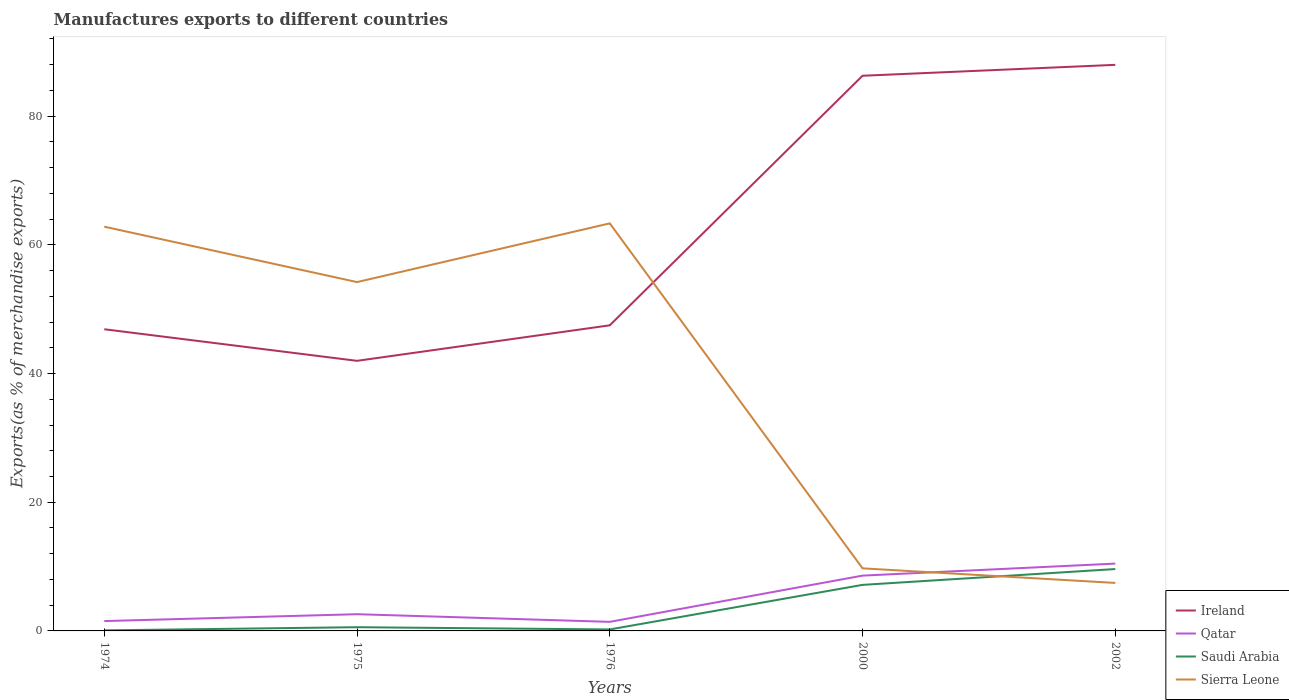How many different coloured lines are there?
Give a very brief answer. 4. Across all years, what is the maximum percentage of exports to different countries in Saudi Arabia?
Keep it short and to the point. 0.09. In which year was the percentage of exports to different countries in Qatar maximum?
Give a very brief answer. 1976. What is the total percentage of exports to different countries in Sierra Leone in the graph?
Keep it short and to the point. -9.13. What is the difference between the highest and the second highest percentage of exports to different countries in Sierra Leone?
Provide a short and direct response. 55.88. How many lines are there?
Your response must be concise. 4. How many years are there in the graph?
Keep it short and to the point. 5. What is the difference between two consecutive major ticks on the Y-axis?
Make the answer very short. 20. Does the graph contain any zero values?
Give a very brief answer. No. Where does the legend appear in the graph?
Provide a short and direct response. Bottom right. How are the legend labels stacked?
Offer a terse response. Vertical. What is the title of the graph?
Your response must be concise. Manufactures exports to different countries. Does "Vietnam" appear as one of the legend labels in the graph?
Give a very brief answer. No. What is the label or title of the X-axis?
Ensure brevity in your answer.  Years. What is the label or title of the Y-axis?
Your answer should be very brief. Exports(as % of merchandise exports). What is the Exports(as % of merchandise exports) of Ireland in 1974?
Your response must be concise. 46.88. What is the Exports(as % of merchandise exports) of Qatar in 1974?
Provide a short and direct response. 1.53. What is the Exports(as % of merchandise exports) of Saudi Arabia in 1974?
Provide a succinct answer. 0.09. What is the Exports(as % of merchandise exports) of Sierra Leone in 1974?
Your response must be concise. 62.82. What is the Exports(as % of merchandise exports) in Ireland in 1975?
Your answer should be compact. 41.97. What is the Exports(as % of merchandise exports) in Qatar in 1975?
Provide a short and direct response. 2.6. What is the Exports(as % of merchandise exports) of Saudi Arabia in 1975?
Give a very brief answer. 0.58. What is the Exports(as % of merchandise exports) in Sierra Leone in 1975?
Your response must be concise. 54.21. What is the Exports(as % of merchandise exports) in Ireland in 1976?
Make the answer very short. 47.49. What is the Exports(as % of merchandise exports) in Qatar in 1976?
Offer a very short reply. 1.41. What is the Exports(as % of merchandise exports) in Saudi Arabia in 1976?
Give a very brief answer. 0.23. What is the Exports(as % of merchandise exports) of Sierra Leone in 1976?
Give a very brief answer. 63.34. What is the Exports(as % of merchandise exports) in Ireland in 2000?
Provide a succinct answer. 86.28. What is the Exports(as % of merchandise exports) in Qatar in 2000?
Your answer should be compact. 8.59. What is the Exports(as % of merchandise exports) in Saudi Arabia in 2000?
Your answer should be compact. 7.16. What is the Exports(as % of merchandise exports) in Sierra Leone in 2000?
Ensure brevity in your answer.  9.73. What is the Exports(as % of merchandise exports) of Ireland in 2002?
Keep it short and to the point. 87.97. What is the Exports(as % of merchandise exports) in Qatar in 2002?
Keep it short and to the point. 10.46. What is the Exports(as % of merchandise exports) in Saudi Arabia in 2002?
Your answer should be very brief. 9.62. What is the Exports(as % of merchandise exports) in Sierra Leone in 2002?
Keep it short and to the point. 7.46. Across all years, what is the maximum Exports(as % of merchandise exports) in Ireland?
Your answer should be compact. 87.97. Across all years, what is the maximum Exports(as % of merchandise exports) of Qatar?
Your answer should be compact. 10.46. Across all years, what is the maximum Exports(as % of merchandise exports) of Saudi Arabia?
Your answer should be very brief. 9.62. Across all years, what is the maximum Exports(as % of merchandise exports) in Sierra Leone?
Your answer should be compact. 63.34. Across all years, what is the minimum Exports(as % of merchandise exports) in Ireland?
Ensure brevity in your answer.  41.97. Across all years, what is the minimum Exports(as % of merchandise exports) in Qatar?
Provide a short and direct response. 1.41. Across all years, what is the minimum Exports(as % of merchandise exports) of Saudi Arabia?
Provide a succinct answer. 0.09. Across all years, what is the minimum Exports(as % of merchandise exports) of Sierra Leone?
Your answer should be compact. 7.46. What is the total Exports(as % of merchandise exports) in Ireland in the graph?
Make the answer very short. 310.6. What is the total Exports(as % of merchandise exports) of Qatar in the graph?
Your answer should be compact. 24.6. What is the total Exports(as % of merchandise exports) of Saudi Arabia in the graph?
Your answer should be compact. 17.67. What is the total Exports(as % of merchandise exports) in Sierra Leone in the graph?
Offer a very short reply. 197.55. What is the difference between the Exports(as % of merchandise exports) in Ireland in 1974 and that in 1975?
Offer a very short reply. 4.91. What is the difference between the Exports(as % of merchandise exports) in Qatar in 1974 and that in 1975?
Provide a succinct answer. -1.07. What is the difference between the Exports(as % of merchandise exports) in Saudi Arabia in 1974 and that in 1975?
Provide a short and direct response. -0.49. What is the difference between the Exports(as % of merchandise exports) in Sierra Leone in 1974 and that in 1975?
Offer a terse response. 8.61. What is the difference between the Exports(as % of merchandise exports) in Ireland in 1974 and that in 1976?
Make the answer very short. -0.61. What is the difference between the Exports(as % of merchandise exports) of Qatar in 1974 and that in 1976?
Your answer should be compact. 0.12. What is the difference between the Exports(as % of merchandise exports) in Saudi Arabia in 1974 and that in 1976?
Keep it short and to the point. -0.14. What is the difference between the Exports(as % of merchandise exports) of Sierra Leone in 1974 and that in 1976?
Give a very brief answer. -0.52. What is the difference between the Exports(as % of merchandise exports) of Ireland in 1974 and that in 2000?
Give a very brief answer. -39.39. What is the difference between the Exports(as % of merchandise exports) of Qatar in 1974 and that in 2000?
Ensure brevity in your answer.  -7.06. What is the difference between the Exports(as % of merchandise exports) in Saudi Arabia in 1974 and that in 2000?
Give a very brief answer. -7.07. What is the difference between the Exports(as % of merchandise exports) of Sierra Leone in 1974 and that in 2000?
Offer a very short reply. 53.1. What is the difference between the Exports(as % of merchandise exports) of Ireland in 1974 and that in 2002?
Ensure brevity in your answer.  -41.09. What is the difference between the Exports(as % of merchandise exports) in Qatar in 1974 and that in 2002?
Ensure brevity in your answer.  -8.93. What is the difference between the Exports(as % of merchandise exports) in Saudi Arabia in 1974 and that in 2002?
Make the answer very short. -9.53. What is the difference between the Exports(as % of merchandise exports) of Sierra Leone in 1974 and that in 2002?
Your response must be concise. 55.36. What is the difference between the Exports(as % of merchandise exports) in Ireland in 1975 and that in 1976?
Provide a succinct answer. -5.52. What is the difference between the Exports(as % of merchandise exports) in Qatar in 1975 and that in 1976?
Give a very brief answer. 1.19. What is the difference between the Exports(as % of merchandise exports) in Saudi Arabia in 1975 and that in 1976?
Keep it short and to the point. 0.35. What is the difference between the Exports(as % of merchandise exports) of Sierra Leone in 1975 and that in 1976?
Keep it short and to the point. -9.13. What is the difference between the Exports(as % of merchandise exports) of Ireland in 1975 and that in 2000?
Offer a terse response. -44.3. What is the difference between the Exports(as % of merchandise exports) of Qatar in 1975 and that in 2000?
Make the answer very short. -6. What is the difference between the Exports(as % of merchandise exports) in Saudi Arabia in 1975 and that in 2000?
Keep it short and to the point. -6.58. What is the difference between the Exports(as % of merchandise exports) in Sierra Leone in 1975 and that in 2000?
Offer a terse response. 44.48. What is the difference between the Exports(as % of merchandise exports) of Ireland in 1975 and that in 2002?
Make the answer very short. -46. What is the difference between the Exports(as % of merchandise exports) of Qatar in 1975 and that in 2002?
Your answer should be compact. -7.86. What is the difference between the Exports(as % of merchandise exports) of Saudi Arabia in 1975 and that in 2002?
Keep it short and to the point. -9.04. What is the difference between the Exports(as % of merchandise exports) of Sierra Leone in 1975 and that in 2002?
Your answer should be very brief. 46.75. What is the difference between the Exports(as % of merchandise exports) in Ireland in 1976 and that in 2000?
Offer a terse response. -38.78. What is the difference between the Exports(as % of merchandise exports) in Qatar in 1976 and that in 2000?
Ensure brevity in your answer.  -7.18. What is the difference between the Exports(as % of merchandise exports) in Saudi Arabia in 1976 and that in 2000?
Make the answer very short. -6.92. What is the difference between the Exports(as % of merchandise exports) of Sierra Leone in 1976 and that in 2000?
Offer a very short reply. 53.61. What is the difference between the Exports(as % of merchandise exports) in Ireland in 1976 and that in 2002?
Give a very brief answer. -40.48. What is the difference between the Exports(as % of merchandise exports) in Qatar in 1976 and that in 2002?
Make the answer very short. -9.05. What is the difference between the Exports(as % of merchandise exports) of Saudi Arabia in 1976 and that in 2002?
Give a very brief answer. -9.38. What is the difference between the Exports(as % of merchandise exports) in Sierra Leone in 1976 and that in 2002?
Your answer should be compact. 55.88. What is the difference between the Exports(as % of merchandise exports) of Ireland in 2000 and that in 2002?
Make the answer very short. -1.69. What is the difference between the Exports(as % of merchandise exports) of Qatar in 2000 and that in 2002?
Offer a terse response. -1.87. What is the difference between the Exports(as % of merchandise exports) of Saudi Arabia in 2000 and that in 2002?
Your response must be concise. -2.46. What is the difference between the Exports(as % of merchandise exports) of Sierra Leone in 2000 and that in 2002?
Your answer should be compact. 2.27. What is the difference between the Exports(as % of merchandise exports) of Ireland in 1974 and the Exports(as % of merchandise exports) of Qatar in 1975?
Offer a terse response. 44.28. What is the difference between the Exports(as % of merchandise exports) in Ireland in 1974 and the Exports(as % of merchandise exports) in Saudi Arabia in 1975?
Keep it short and to the point. 46.3. What is the difference between the Exports(as % of merchandise exports) of Ireland in 1974 and the Exports(as % of merchandise exports) of Sierra Leone in 1975?
Ensure brevity in your answer.  -7.33. What is the difference between the Exports(as % of merchandise exports) in Qatar in 1974 and the Exports(as % of merchandise exports) in Saudi Arabia in 1975?
Your answer should be very brief. 0.95. What is the difference between the Exports(as % of merchandise exports) of Qatar in 1974 and the Exports(as % of merchandise exports) of Sierra Leone in 1975?
Provide a succinct answer. -52.68. What is the difference between the Exports(as % of merchandise exports) in Saudi Arabia in 1974 and the Exports(as % of merchandise exports) in Sierra Leone in 1975?
Keep it short and to the point. -54.12. What is the difference between the Exports(as % of merchandise exports) in Ireland in 1974 and the Exports(as % of merchandise exports) in Qatar in 1976?
Make the answer very short. 45.47. What is the difference between the Exports(as % of merchandise exports) in Ireland in 1974 and the Exports(as % of merchandise exports) in Saudi Arabia in 1976?
Offer a terse response. 46.65. What is the difference between the Exports(as % of merchandise exports) of Ireland in 1974 and the Exports(as % of merchandise exports) of Sierra Leone in 1976?
Offer a very short reply. -16.45. What is the difference between the Exports(as % of merchandise exports) in Qatar in 1974 and the Exports(as % of merchandise exports) in Saudi Arabia in 1976?
Give a very brief answer. 1.3. What is the difference between the Exports(as % of merchandise exports) of Qatar in 1974 and the Exports(as % of merchandise exports) of Sierra Leone in 1976?
Provide a short and direct response. -61.81. What is the difference between the Exports(as % of merchandise exports) of Saudi Arabia in 1974 and the Exports(as % of merchandise exports) of Sierra Leone in 1976?
Offer a terse response. -63.25. What is the difference between the Exports(as % of merchandise exports) of Ireland in 1974 and the Exports(as % of merchandise exports) of Qatar in 2000?
Give a very brief answer. 38.29. What is the difference between the Exports(as % of merchandise exports) of Ireland in 1974 and the Exports(as % of merchandise exports) of Saudi Arabia in 2000?
Ensure brevity in your answer.  39.73. What is the difference between the Exports(as % of merchandise exports) in Ireland in 1974 and the Exports(as % of merchandise exports) in Sierra Leone in 2000?
Your answer should be very brief. 37.16. What is the difference between the Exports(as % of merchandise exports) of Qatar in 1974 and the Exports(as % of merchandise exports) of Saudi Arabia in 2000?
Offer a very short reply. -5.62. What is the difference between the Exports(as % of merchandise exports) of Qatar in 1974 and the Exports(as % of merchandise exports) of Sierra Leone in 2000?
Offer a terse response. -8.19. What is the difference between the Exports(as % of merchandise exports) in Saudi Arabia in 1974 and the Exports(as % of merchandise exports) in Sierra Leone in 2000?
Your response must be concise. -9.64. What is the difference between the Exports(as % of merchandise exports) of Ireland in 1974 and the Exports(as % of merchandise exports) of Qatar in 2002?
Offer a very short reply. 36.42. What is the difference between the Exports(as % of merchandise exports) of Ireland in 1974 and the Exports(as % of merchandise exports) of Saudi Arabia in 2002?
Offer a terse response. 37.27. What is the difference between the Exports(as % of merchandise exports) of Ireland in 1974 and the Exports(as % of merchandise exports) of Sierra Leone in 2002?
Give a very brief answer. 39.42. What is the difference between the Exports(as % of merchandise exports) of Qatar in 1974 and the Exports(as % of merchandise exports) of Saudi Arabia in 2002?
Offer a very short reply. -8.08. What is the difference between the Exports(as % of merchandise exports) of Qatar in 1974 and the Exports(as % of merchandise exports) of Sierra Leone in 2002?
Offer a terse response. -5.93. What is the difference between the Exports(as % of merchandise exports) of Saudi Arabia in 1974 and the Exports(as % of merchandise exports) of Sierra Leone in 2002?
Keep it short and to the point. -7.37. What is the difference between the Exports(as % of merchandise exports) in Ireland in 1975 and the Exports(as % of merchandise exports) in Qatar in 1976?
Give a very brief answer. 40.56. What is the difference between the Exports(as % of merchandise exports) of Ireland in 1975 and the Exports(as % of merchandise exports) of Saudi Arabia in 1976?
Keep it short and to the point. 41.74. What is the difference between the Exports(as % of merchandise exports) in Ireland in 1975 and the Exports(as % of merchandise exports) in Sierra Leone in 1976?
Provide a short and direct response. -21.36. What is the difference between the Exports(as % of merchandise exports) of Qatar in 1975 and the Exports(as % of merchandise exports) of Saudi Arabia in 1976?
Make the answer very short. 2.37. What is the difference between the Exports(as % of merchandise exports) in Qatar in 1975 and the Exports(as % of merchandise exports) in Sierra Leone in 1976?
Provide a succinct answer. -60.74. What is the difference between the Exports(as % of merchandise exports) of Saudi Arabia in 1975 and the Exports(as % of merchandise exports) of Sierra Leone in 1976?
Offer a very short reply. -62.76. What is the difference between the Exports(as % of merchandise exports) of Ireland in 1975 and the Exports(as % of merchandise exports) of Qatar in 2000?
Offer a terse response. 33.38. What is the difference between the Exports(as % of merchandise exports) of Ireland in 1975 and the Exports(as % of merchandise exports) of Saudi Arabia in 2000?
Offer a terse response. 34.82. What is the difference between the Exports(as % of merchandise exports) of Ireland in 1975 and the Exports(as % of merchandise exports) of Sierra Leone in 2000?
Provide a short and direct response. 32.25. What is the difference between the Exports(as % of merchandise exports) in Qatar in 1975 and the Exports(as % of merchandise exports) in Saudi Arabia in 2000?
Ensure brevity in your answer.  -4.56. What is the difference between the Exports(as % of merchandise exports) of Qatar in 1975 and the Exports(as % of merchandise exports) of Sierra Leone in 2000?
Keep it short and to the point. -7.13. What is the difference between the Exports(as % of merchandise exports) of Saudi Arabia in 1975 and the Exports(as % of merchandise exports) of Sierra Leone in 2000?
Ensure brevity in your answer.  -9.15. What is the difference between the Exports(as % of merchandise exports) in Ireland in 1975 and the Exports(as % of merchandise exports) in Qatar in 2002?
Keep it short and to the point. 31.51. What is the difference between the Exports(as % of merchandise exports) in Ireland in 1975 and the Exports(as % of merchandise exports) in Saudi Arabia in 2002?
Provide a short and direct response. 32.36. What is the difference between the Exports(as % of merchandise exports) in Ireland in 1975 and the Exports(as % of merchandise exports) in Sierra Leone in 2002?
Provide a short and direct response. 34.52. What is the difference between the Exports(as % of merchandise exports) in Qatar in 1975 and the Exports(as % of merchandise exports) in Saudi Arabia in 2002?
Your answer should be compact. -7.02. What is the difference between the Exports(as % of merchandise exports) of Qatar in 1975 and the Exports(as % of merchandise exports) of Sierra Leone in 2002?
Offer a very short reply. -4.86. What is the difference between the Exports(as % of merchandise exports) of Saudi Arabia in 1975 and the Exports(as % of merchandise exports) of Sierra Leone in 2002?
Provide a short and direct response. -6.88. What is the difference between the Exports(as % of merchandise exports) of Ireland in 1976 and the Exports(as % of merchandise exports) of Qatar in 2000?
Keep it short and to the point. 38.9. What is the difference between the Exports(as % of merchandise exports) in Ireland in 1976 and the Exports(as % of merchandise exports) in Saudi Arabia in 2000?
Offer a very short reply. 40.34. What is the difference between the Exports(as % of merchandise exports) in Ireland in 1976 and the Exports(as % of merchandise exports) in Sierra Leone in 2000?
Give a very brief answer. 37.77. What is the difference between the Exports(as % of merchandise exports) in Qatar in 1976 and the Exports(as % of merchandise exports) in Saudi Arabia in 2000?
Keep it short and to the point. -5.74. What is the difference between the Exports(as % of merchandise exports) of Qatar in 1976 and the Exports(as % of merchandise exports) of Sierra Leone in 2000?
Offer a terse response. -8.32. What is the difference between the Exports(as % of merchandise exports) in Saudi Arabia in 1976 and the Exports(as % of merchandise exports) in Sierra Leone in 2000?
Ensure brevity in your answer.  -9.49. What is the difference between the Exports(as % of merchandise exports) in Ireland in 1976 and the Exports(as % of merchandise exports) in Qatar in 2002?
Give a very brief answer. 37.03. What is the difference between the Exports(as % of merchandise exports) in Ireland in 1976 and the Exports(as % of merchandise exports) in Saudi Arabia in 2002?
Provide a short and direct response. 37.88. What is the difference between the Exports(as % of merchandise exports) of Ireland in 1976 and the Exports(as % of merchandise exports) of Sierra Leone in 2002?
Your response must be concise. 40.04. What is the difference between the Exports(as % of merchandise exports) in Qatar in 1976 and the Exports(as % of merchandise exports) in Saudi Arabia in 2002?
Make the answer very short. -8.2. What is the difference between the Exports(as % of merchandise exports) in Qatar in 1976 and the Exports(as % of merchandise exports) in Sierra Leone in 2002?
Your answer should be very brief. -6.05. What is the difference between the Exports(as % of merchandise exports) in Saudi Arabia in 1976 and the Exports(as % of merchandise exports) in Sierra Leone in 2002?
Offer a very short reply. -7.23. What is the difference between the Exports(as % of merchandise exports) in Ireland in 2000 and the Exports(as % of merchandise exports) in Qatar in 2002?
Offer a terse response. 75.81. What is the difference between the Exports(as % of merchandise exports) in Ireland in 2000 and the Exports(as % of merchandise exports) in Saudi Arabia in 2002?
Offer a very short reply. 76.66. What is the difference between the Exports(as % of merchandise exports) in Ireland in 2000 and the Exports(as % of merchandise exports) in Sierra Leone in 2002?
Make the answer very short. 78.82. What is the difference between the Exports(as % of merchandise exports) of Qatar in 2000 and the Exports(as % of merchandise exports) of Saudi Arabia in 2002?
Offer a very short reply. -1.02. What is the difference between the Exports(as % of merchandise exports) of Qatar in 2000 and the Exports(as % of merchandise exports) of Sierra Leone in 2002?
Your answer should be very brief. 1.14. What is the difference between the Exports(as % of merchandise exports) in Saudi Arabia in 2000 and the Exports(as % of merchandise exports) in Sierra Leone in 2002?
Provide a succinct answer. -0.3. What is the average Exports(as % of merchandise exports) of Ireland per year?
Your answer should be compact. 62.12. What is the average Exports(as % of merchandise exports) in Qatar per year?
Give a very brief answer. 4.92. What is the average Exports(as % of merchandise exports) in Saudi Arabia per year?
Make the answer very short. 3.53. What is the average Exports(as % of merchandise exports) of Sierra Leone per year?
Make the answer very short. 39.51. In the year 1974, what is the difference between the Exports(as % of merchandise exports) of Ireland and Exports(as % of merchandise exports) of Qatar?
Ensure brevity in your answer.  45.35. In the year 1974, what is the difference between the Exports(as % of merchandise exports) of Ireland and Exports(as % of merchandise exports) of Saudi Arabia?
Ensure brevity in your answer.  46.8. In the year 1974, what is the difference between the Exports(as % of merchandise exports) in Ireland and Exports(as % of merchandise exports) in Sierra Leone?
Your answer should be very brief. -15.94. In the year 1974, what is the difference between the Exports(as % of merchandise exports) of Qatar and Exports(as % of merchandise exports) of Saudi Arabia?
Make the answer very short. 1.44. In the year 1974, what is the difference between the Exports(as % of merchandise exports) of Qatar and Exports(as % of merchandise exports) of Sierra Leone?
Your answer should be very brief. -61.29. In the year 1974, what is the difference between the Exports(as % of merchandise exports) of Saudi Arabia and Exports(as % of merchandise exports) of Sierra Leone?
Ensure brevity in your answer.  -62.73. In the year 1975, what is the difference between the Exports(as % of merchandise exports) in Ireland and Exports(as % of merchandise exports) in Qatar?
Make the answer very short. 39.38. In the year 1975, what is the difference between the Exports(as % of merchandise exports) of Ireland and Exports(as % of merchandise exports) of Saudi Arabia?
Offer a terse response. 41.4. In the year 1975, what is the difference between the Exports(as % of merchandise exports) in Ireland and Exports(as % of merchandise exports) in Sierra Leone?
Make the answer very short. -12.24. In the year 1975, what is the difference between the Exports(as % of merchandise exports) of Qatar and Exports(as % of merchandise exports) of Saudi Arabia?
Make the answer very short. 2.02. In the year 1975, what is the difference between the Exports(as % of merchandise exports) in Qatar and Exports(as % of merchandise exports) in Sierra Leone?
Your answer should be very brief. -51.61. In the year 1975, what is the difference between the Exports(as % of merchandise exports) of Saudi Arabia and Exports(as % of merchandise exports) of Sierra Leone?
Make the answer very short. -53.63. In the year 1976, what is the difference between the Exports(as % of merchandise exports) of Ireland and Exports(as % of merchandise exports) of Qatar?
Offer a very short reply. 46.08. In the year 1976, what is the difference between the Exports(as % of merchandise exports) in Ireland and Exports(as % of merchandise exports) in Saudi Arabia?
Your answer should be very brief. 47.26. In the year 1976, what is the difference between the Exports(as % of merchandise exports) in Ireland and Exports(as % of merchandise exports) in Sierra Leone?
Offer a very short reply. -15.84. In the year 1976, what is the difference between the Exports(as % of merchandise exports) in Qatar and Exports(as % of merchandise exports) in Saudi Arabia?
Offer a terse response. 1.18. In the year 1976, what is the difference between the Exports(as % of merchandise exports) of Qatar and Exports(as % of merchandise exports) of Sierra Leone?
Give a very brief answer. -61.93. In the year 1976, what is the difference between the Exports(as % of merchandise exports) in Saudi Arabia and Exports(as % of merchandise exports) in Sierra Leone?
Your response must be concise. -63.11. In the year 2000, what is the difference between the Exports(as % of merchandise exports) in Ireland and Exports(as % of merchandise exports) in Qatar?
Your response must be concise. 77.68. In the year 2000, what is the difference between the Exports(as % of merchandise exports) in Ireland and Exports(as % of merchandise exports) in Saudi Arabia?
Provide a succinct answer. 79.12. In the year 2000, what is the difference between the Exports(as % of merchandise exports) of Ireland and Exports(as % of merchandise exports) of Sierra Leone?
Ensure brevity in your answer.  76.55. In the year 2000, what is the difference between the Exports(as % of merchandise exports) in Qatar and Exports(as % of merchandise exports) in Saudi Arabia?
Your response must be concise. 1.44. In the year 2000, what is the difference between the Exports(as % of merchandise exports) in Qatar and Exports(as % of merchandise exports) in Sierra Leone?
Your answer should be very brief. -1.13. In the year 2000, what is the difference between the Exports(as % of merchandise exports) in Saudi Arabia and Exports(as % of merchandise exports) in Sierra Leone?
Your response must be concise. -2.57. In the year 2002, what is the difference between the Exports(as % of merchandise exports) in Ireland and Exports(as % of merchandise exports) in Qatar?
Provide a short and direct response. 77.51. In the year 2002, what is the difference between the Exports(as % of merchandise exports) in Ireland and Exports(as % of merchandise exports) in Saudi Arabia?
Offer a very short reply. 78.36. In the year 2002, what is the difference between the Exports(as % of merchandise exports) of Ireland and Exports(as % of merchandise exports) of Sierra Leone?
Make the answer very short. 80.51. In the year 2002, what is the difference between the Exports(as % of merchandise exports) in Qatar and Exports(as % of merchandise exports) in Saudi Arabia?
Your answer should be compact. 0.85. In the year 2002, what is the difference between the Exports(as % of merchandise exports) of Qatar and Exports(as % of merchandise exports) of Sierra Leone?
Provide a short and direct response. 3. In the year 2002, what is the difference between the Exports(as % of merchandise exports) in Saudi Arabia and Exports(as % of merchandise exports) in Sierra Leone?
Provide a succinct answer. 2.16. What is the ratio of the Exports(as % of merchandise exports) of Ireland in 1974 to that in 1975?
Your answer should be very brief. 1.12. What is the ratio of the Exports(as % of merchandise exports) of Qatar in 1974 to that in 1975?
Offer a terse response. 0.59. What is the ratio of the Exports(as % of merchandise exports) in Saudi Arabia in 1974 to that in 1975?
Your response must be concise. 0.15. What is the ratio of the Exports(as % of merchandise exports) in Sierra Leone in 1974 to that in 1975?
Give a very brief answer. 1.16. What is the ratio of the Exports(as % of merchandise exports) in Ireland in 1974 to that in 1976?
Provide a succinct answer. 0.99. What is the ratio of the Exports(as % of merchandise exports) in Qatar in 1974 to that in 1976?
Provide a succinct answer. 1.09. What is the ratio of the Exports(as % of merchandise exports) of Saudi Arabia in 1974 to that in 1976?
Your answer should be very brief. 0.38. What is the ratio of the Exports(as % of merchandise exports) of Sierra Leone in 1974 to that in 1976?
Make the answer very short. 0.99. What is the ratio of the Exports(as % of merchandise exports) in Ireland in 1974 to that in 2000?
Your answer should be very brief. 0.54. What is the ratio of the Exports(as % of merchandise exports) in Qatar in 1974 to that in 2000?
Make the answer very short. 0.18. What is the ratio of the Exports(as % of merchandise exports) in Saudi Arabia in 1974 to that in 2000?
Provide a succinct answer. 0.01. What is the ratio of the Exports(as % of merchandise exports) of Sierra Leone in 1974 to that in 2000?
Offer a very short reply. 6.46. What is the ratio of the Exports(as % of merchandise exports) in Ireland in 1974 to that in 2002?
Keep it short and to the point. 0.53. What is the ratio of the Exports(as % of merchandise exports) in Qatar in 1974 to that in 2002?
Your answer should be very brief. 0.15. What is the ratio of the Exports(as % of merchandise exports) in Saudi Arabia in 1974 to that in 2002?
Your answer should be very brief. 0.01. What is the ratio of the Exports(as % of merchandise exports) in Sierra Leone in 1974 to that in 2002?
Your answer should be compact. 8.42. What is the ratio of the Exports(as % of merchandise exports) in Ireland in 1975 to that in 1976?
Make the answer very short. 0.88. What is the ratio of the Exports(as % of merchandise exports) in Qatar in 1975 to that in 1976?
Offer a terse response. 1.84. What is the ratio of the Exports(as % of merchandise exports) of Saudi Arabia in 1975 to that in 1976?
Provide a short and direct response. 2.5. What is the ratio of the Exports(as % of merchandise exports) of Sierra Leone in 1975 to that in 1976?
Offer a terse response. 0.86. What is the ratio of the Exports(as % of merchandise exports) of Ireland in 1975 to that in 2000?
Provide a short and direct response. 0.49. What is the ratio of the Exports(as % of merchandise exports) of Qatar in 1975 to that in 2000?
Your response must be concise. 0.3. What is the ratio of the Exports(as % of merchandise exports) in Saudi Arabia in 1975 to that in 2000?
Keep it short and to the point. 0.08. What is the ratio of the Exports(as % of merchandise exports) of Sierra Leone in 1975 to that in 2000?
Your answer should be compact. 5.57. What is the ratio of the Exports(as % of merchandise exports) of Ireland in 1975 to that in 2002?
Your response must be concise. 0.48. What is the ratio of the Exports(as % of merchandise exports) of Qatar in 1975 to that in 2002?
Give a very brief answer. 0.25. What is the ratio of the Exports(as % of merchandise exports) of Saudi Arabia in 1975 to that in 2002?
Keep it short and to the point. 0.06. What is the ratio of the Exports(as % of merchandise exports) of Sierra Leone in 1975 to that in 2002?
Give a very brief answer. 7.27. What is the ratio of the Exports(as % of merchandise exports) in Ireland in 1976 to that in 2000?
Your answer should be compact. 0.55. What is the ratio of the Exports(as % of merchandise exports) of Qatar in 1976 to that in 2000?
Provide a short and direct response. 0.16. What is the ratio of the Exports(as % of merchandise exports) of Saudi Arabia in 1976 to that in 2000?
Make the answer very short. 0.03. What is the ratio of the Exports(as % of merchandise exports) of Sierra Leone in 1976 to that in 2000?
Provide a short and direct response. 6.51. What is the ratio of the Exports(as % of merchandise exports) of Ireland in 1976 to that in 2002?
Your response must be concise. 0.54. What is the ratio of the Exports(as % of merchandise exports) of Qatar in 1976 to that in 2002?
Offer a very short reply. 0.13. What is the ratio of the Exports(as % of merchandise exports) of Saudi Arabia in 1976 to that in 2002?
Ensure brevity in your answer.  0.02. What is the ratio of the Exports(as % of merchandise exports) of Sierra Leone in 1976 to that in 2002?
Your answer should be compact. 8.49. What is the ratio of the Exports(as % of merchandise exports) in Ireland in 2000 to that in 2002?
Provide a short and direct response. 0.98. What is the ratio of the Exports(as % of merchandise exports) in Qatar in 2000 to that in 2002?
Ensure brevity in your answer.  0.82. What is the ratio of the Exports(as % of merchandise exports) in Saudi Arabia in 2000 to that in 2002?
Offer a terse response. 0.74. What is the ratio of the Exports(as % of merchandise exports) of Sierra Leone in 2000 to that in 2002?
Your answer should be very brief. 1.3. What is the difference between the highest and the second highest Exports(as % of merchandise exports) of Ireland?
Ensure brevity in your answer.  1.69. What is the difference between the highest and the second highest Exports(as % of merchandise exports) in Qatar?
Ensure brevity in your answer.  1.87. What is the difference between the highest and the second highest Exports(as % of merchandise exports) in Saudi Arabia?
Provide a succinct answer. 2.46. What is the difference between the highest and the second highest Exports(as % of merchandise exports) of Sierra Leone?
Your answer should be compact. 0.52. What is the difference between the highest and the lowest Exports(as % of merchandise exports) of Ireland?
Give a very brief answer. 46. What is the difference between the highest and the lowest Exports(as % of merchandise exports) in Qatar?
Ensure brevity in your answer.  9.05. What is the difference between the highest and the lowest Exports(as % of merchandise exports) in Saudi Arabia?
Provide a succinct answer. 9.53. What is the difference between the highest and the lowest Exports(as % of merchandise exports) in Sierra Leone?
Ensure brevity in your answer.  55.88. 